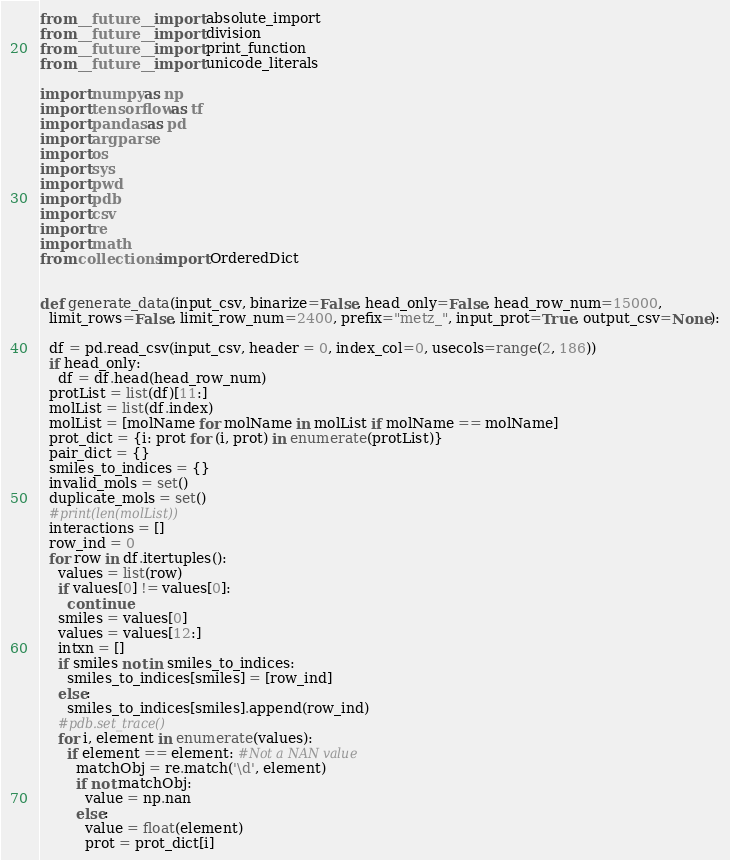<code> <loc_0><loc_0><loc_500><loc_500><_Python_>from __future__ import absolute_import
from __future__ import division
from __future__ import print_function
from __future__ import unicode_literals

import numpy as np
import tensorflow as tf
import pandas as pd
import argparse
import os
import sys
import pwd
import pdb
import csv
import re
import math
from collections import OrderedDict


def generate_data(input_csv, binarize=False, head_only=False, head_row_num=15000, 
  limit_rows=False, limit_row_num=2400, prefix="metz_", input_prot=True, output_csv=None):

  df = pd.read_csv(input_csv, header = 0, index_col=0, usecols=range(2, 186))
  if head_only:
    df = df.head(head_row_num)
  protList = list(df)[11:]
  molList = list(df.index)
  molList = [molName for molName in molList if molName == molName]
  prot_dict = {i: prot for (i, prot) in enumerate(protList)}
  pair_dict = {}
  smiles_to_indices = {}
  invalid_mols = set()
  duplicate_mols = set()
  #print(len(molList))
  interactions = []
  row_ind = 0
  for row in df.itertuples():  
    values = list(row)
    if values[0] != values[0]:
      continue
    smiles = values[0]
    values = values[12:]
    intxn = []
    if smiles not in smiles_to_indices:
      smiles_to_indices[smiles] = [row_ind]
    else:
      smiles_to_indices[smiles].append(row_ind)
    #pdb.set_trace()  
    for i, element in enumerate(values):
      if element == element: #Not a NAN value
        matchObj = re.match('\d', element)
        if not matchObj:
          value = np.nan
        else:
          value = float(element)
          prot = prot_dict[i]        </code> 